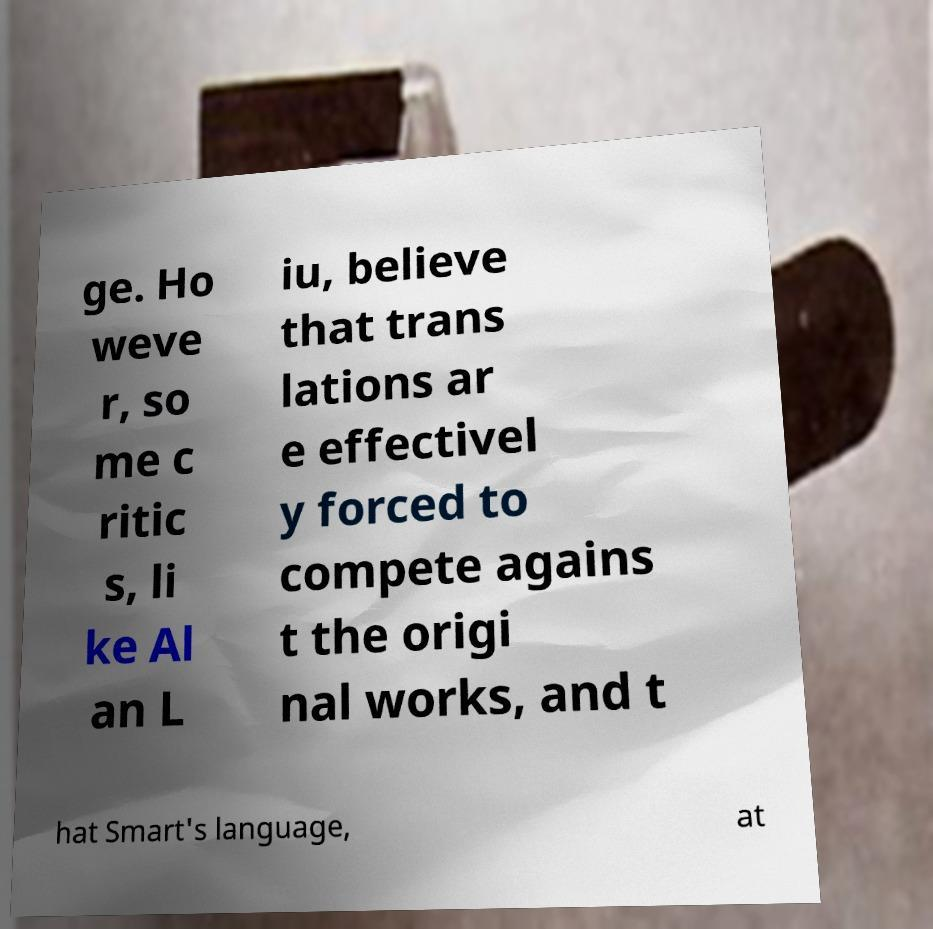What messages or text are displayed in this image? I need them in a readable, typed format. ge. Ho weve r, so me c ritic s, li ke Al an L iu, believe that trans lations ar e effectivel y forced to compete agains t the origi nal works, and t hat Smart's language, at 